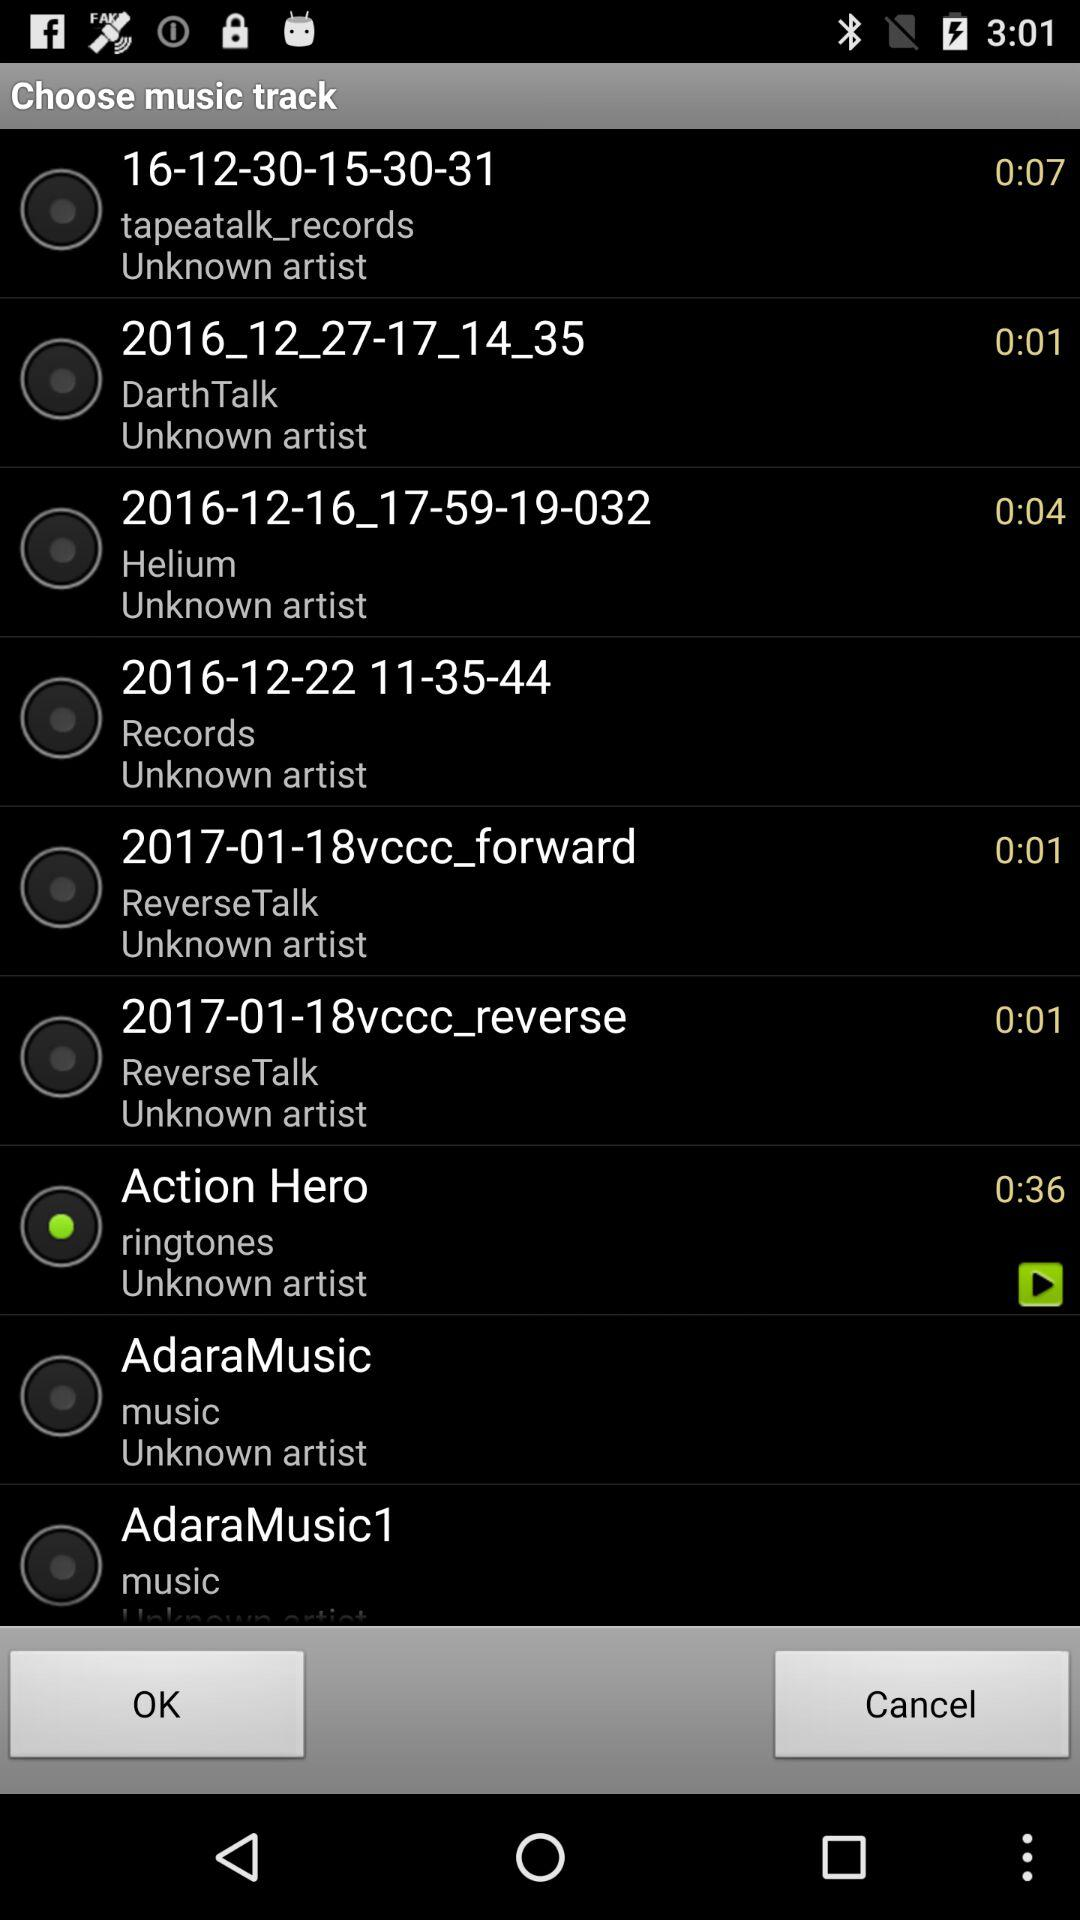How many music tracks are available?
Answer the question using a single word or phrase. 9 